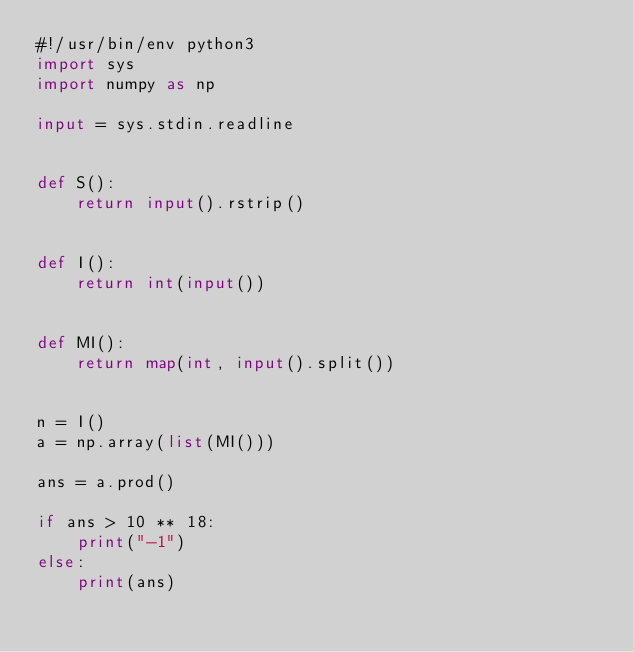<code> <loc_0><loc_0><loc_500><loc_500><_Python_>#!/usr/bin/env python3
import sys
import numpy as np

input = sys.stdin.readline


def S():
    return input().rstrip()


def I():
    return int(input())


def MI():
    return map(int, input().split())


n = I()
a = np.array(list(MI()))

ans = a.prod()

if ans > 10 ** 18:
    print("-1")
else:
    print(ans)
</code> 